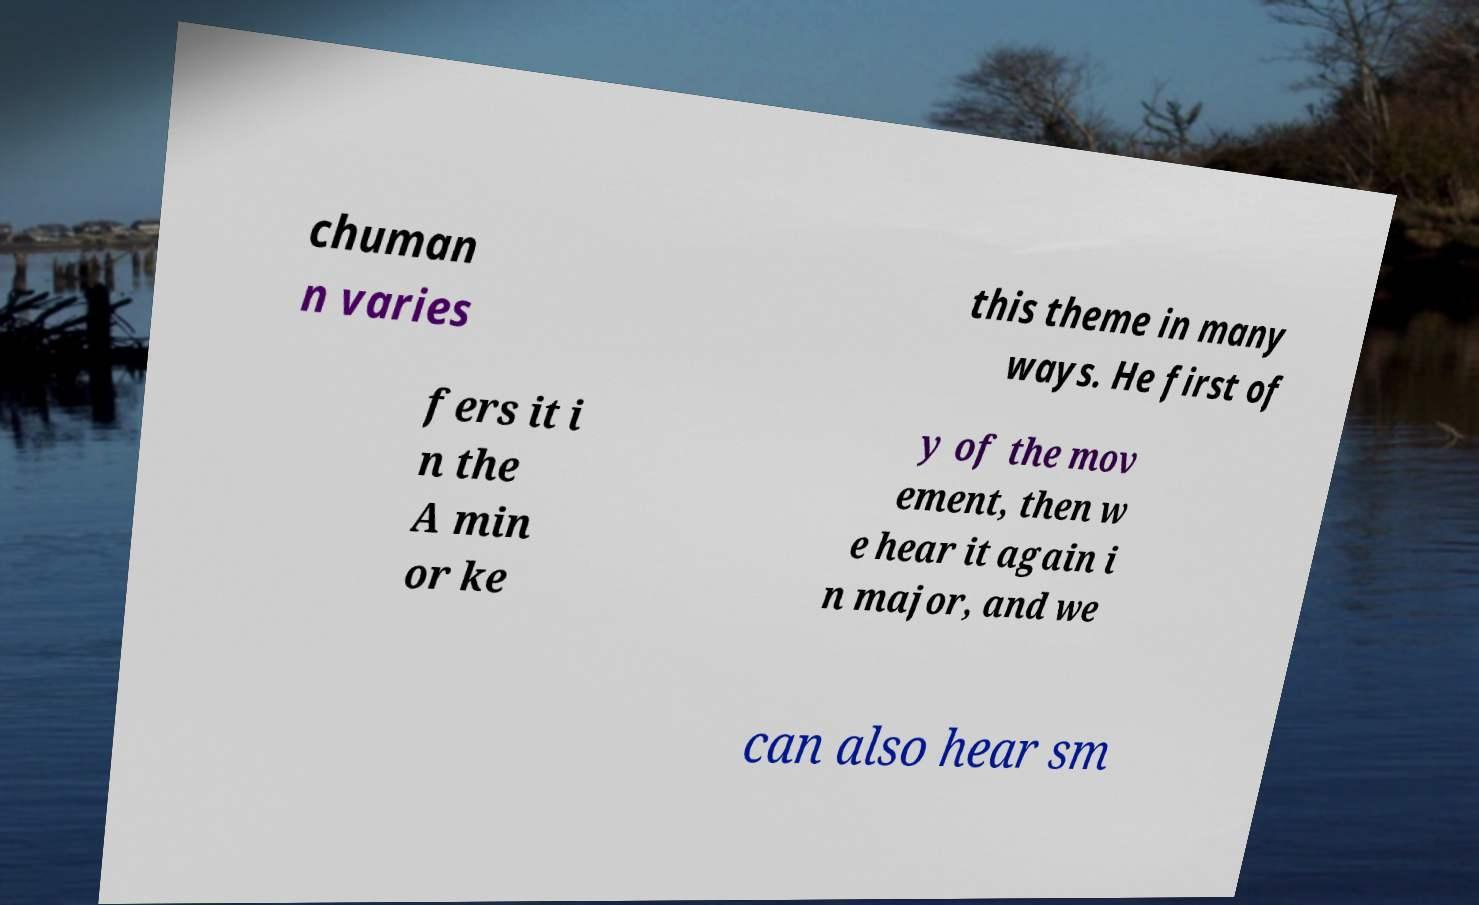Could you assist in decoding the text presented in this image and type it out clearly? chuman n varies this theme in many ways. He first of fers it i n the A min or ke y of the mov ement, then w e hear it again i n major, and we can also hear sm 